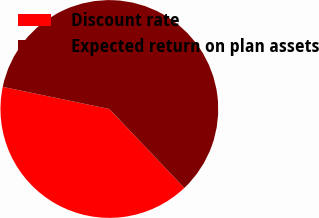Convert chart. <chart><loc_0><loc_0><loc_500><loc_500><pie_chart><fcel>Discount rate<fcel>Expected return on plan assets<nl><fcel>40.35%<fcel>59.65%<nl></chart> 